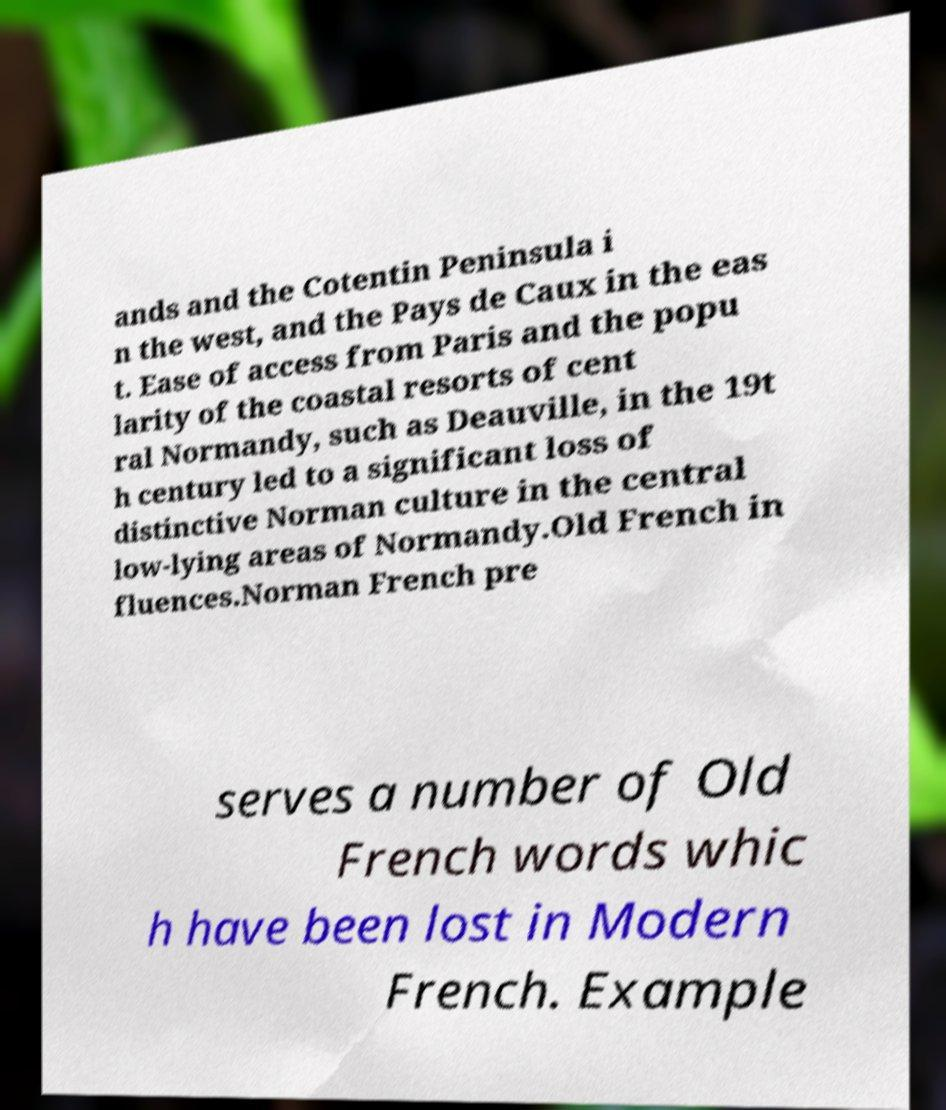Please identify and transcribe the text found in this image. ands and the Cotentin Peninsula i n the west, and the Pays de Caux in the eas t. Ease of access from Paris and the popu larity of the coastal resorts of cent ral Normandy, such as Deauville, in the 19t h century led to a significant loss of distinctive Norman culture in the central low-lying areas of Normandy.Old French in fluences.Norman French pre serves a number of Old French words whic h have been lost in Modern French. Example 